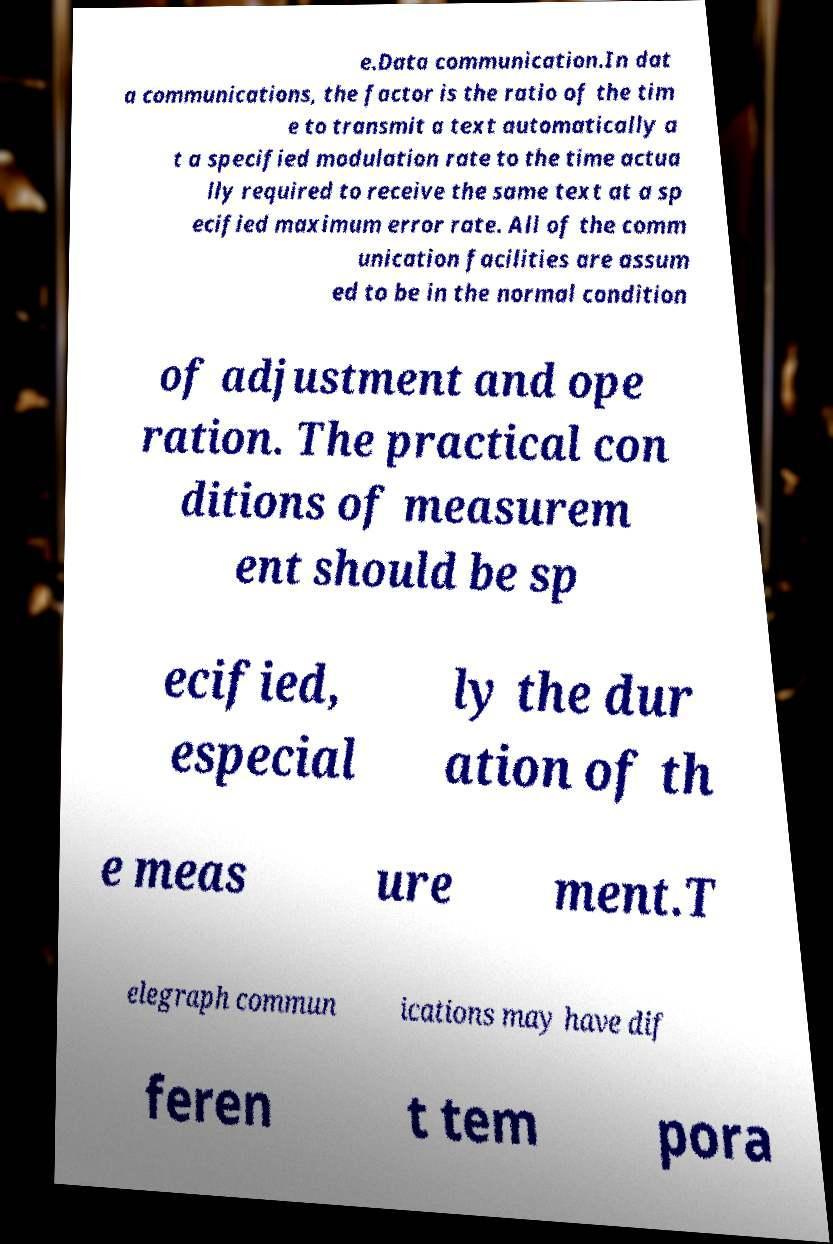There's text embedded in this image that I need extracted. Can you transcribe it verbatim? e.Data communication.In dat a communications, the factor is the ratio of the tim e to transmit a text automatically a t a specified modulation rate to the time actua lly required to receive the same text at a sp ecified maximum error rate. All of the comm unication facilities are assum ed to be in the normal condition of adjustment and ope ration. The practical con ditions of measurem ent should be sp ecified, especial ly the dur ation of th e meas ure ment.T elegraph commun ications may have dif feren t tem pora 